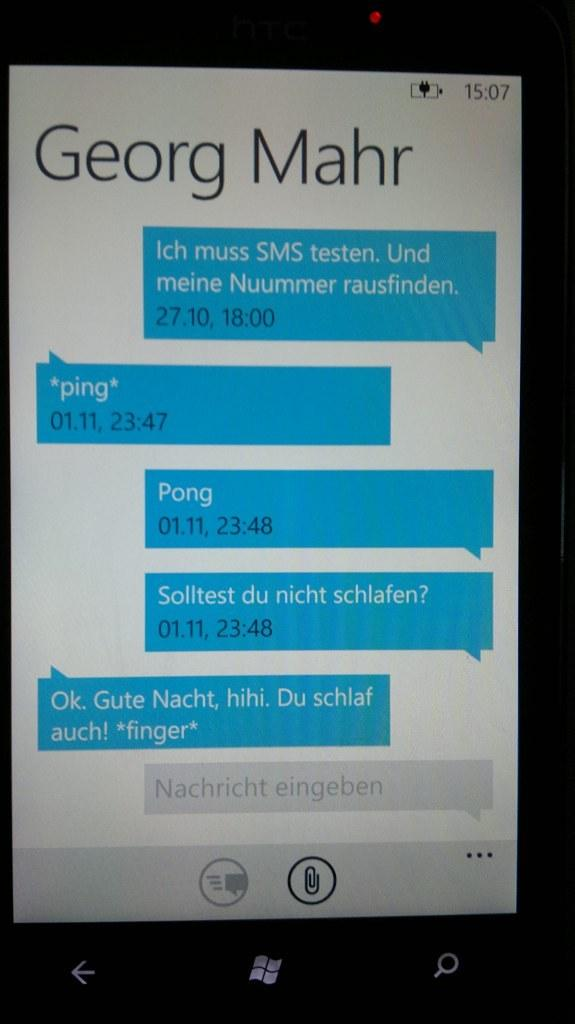<image>
Describe the image concisely. a screen shot of a conversation from Georg Mahr 